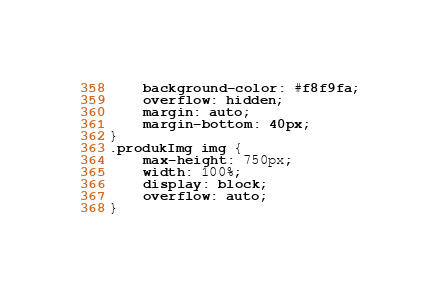Convert code to text. <code><loc_0><loc_0><loc_500><loc_500><_CSS_>	background-color: #f8f9fa;
    overflow: hidden;
    margin: auto;
    margin-bottom: 40px;
}
.produkImg img {
    max-height: 750px;
    width: 100%;
    display: block;
    overflow: auto;
}</code> 